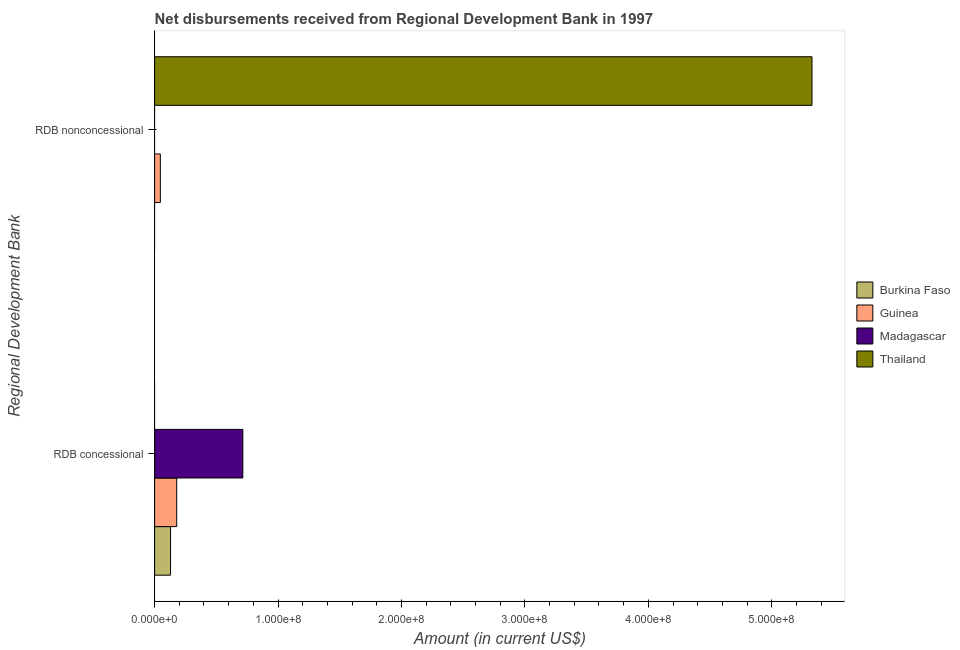Are the number of bars per tick equal to the number of legend labels?
Provide a succinct answer. No. Are the number of bars on each tick of the Y-axis equal?
Your response must be concise. No. How many bars are there on the 2nd tick from the top?
Ensure brevity in your answer.  3. How many bars are there on the 1st tick from the bottom?
Provide a short and direct response. 3. What is the label of the 1st group of bars from the top?
Your response must be concise. RDB nonconcessional. What is the net concessional disbursements from rdb in Madagascar?
Give a very brief answer. 7.15e+07. Across all countries, what is the maximum net concessional disbursements from rdb?
Offer a very short reply. 7.15e+07. Across all countries, what is the minimum net concessional disbursements from rdb?
Ensure brevity in your answer.  0. In which country was the net concessional disbursements from rdb maximum?
Offer a very short reply. Madagascar. What is the total net concessional disbursements from rdb in the graph?
Give a very brief answer. 1.02e+08. What is the difference between the net concessional disbursements from rdb in Madagascar and that in Burkina Faso?
Keep it short and to the point. 5.86e+07. What is the difference between the net concessional disbursements from rdb in Burkina Faso and the net non concessional disbursements from rdb in Thailand?
Your answer should be compact. -5.20e+08. What is the average net concessional disbursements from rdb per country?
Offer a very short reply. 2.56e+07. What is the difference between the net concessional disbursements from rdb and net non concessional disbursements from rdb in Guinea?
Give a very brief answer. 1.33e+07. In how many countries, is the net concessional disbursements from rdb greater than 200000000 US$?
Give a very brief answer. 0. What is the ratio of the net concessional disbursements from rdb in Burkina Faso to that in Madagascar?
Offer a very short reply. 0.18. In how many countries, is the net concessional disbursements from rdb greater than the average net concessional disbursements from rdb taken over all countries?
Your response must be concise. 1. How many countries are there in the graph?
Keep it short and to the point. 4. Does the graph contain any zero values?
Give a very brief answer. Yes. Where does the legend appear in the graph?
Keep it short and to the point. Center right. How are the legend labels stacked?
Your answer should be compact. Vertical. What is the title of the graph?
Provide a succinct answer. Net disbursements received from Regional Development Bank in 1997. What is the label or title of the X-axis?
Your answer should be very brief. Amount (in current US$). What is the label or title of the Y-axis?
Keep it short and to the point. Regional Development Bank. What is the Amount (in current US$) of Burkina Faso in RDB concessional?
Provide a succinct answer. 1.29e+07. What is the Amount (in current US$) in Guinea in RDB concessional?
Your answer should be compact. 1.79e+07. What is the Amount (in current US$) in Madagascar in RDB concessional?
Your answer should be very brief. 7.15e+07. What is the Amount (in current US$) of Burkina Faso in RDB nonconcessional?
Keep it short and to the point. 0. What is the Amount (in current US$) of Guinea in RDB nonconcessional?
Your answer should be compact. 4.65e+06. What is the Amount (in current US$) of Madagascar in RDB nonconcessional?
Offer a terse response. 0. What is the Amount (in current US$) in Thailand in RDB nonconcessional?
Make the answer very short. 5.33e+08. Across all Regional Development Bank, what is the maximum Amount (in current US$) of Burkina Faso?
Provide a short and direct response. 1.29e+07. Across all Regional Development Bank, what is the maximum Amount (in current US$) of Guinea?
Offer a very short reply. 1.79e+07. Across all Regional Development Bank, what is the maximum Amount (in current US$) of Madagascar?
Offer a terse response. 7.15e+07. Across all Regional Development Bank, what is the maximum Amount (in current US$) in Thailand?
Your answer should be compact. 5.33e+08. Across all Regional Development Bank, what is the minimum Amount (in current US$) in Guinea?
Provide a succinct answer. 4.65e+06. Across all Regional Development Bank, what is the minimum Amount (in current US$) of Madagascar?
Ensure brevity in your answer.  0. What is the total Amount (in current US$) of Burkina Faso in the graph?
Your answer should be compact. 1.29e+07. What is the total Amount (in current US$) of Guinea in the graph?
Make the answer very short. 2.26e+07. What is the total Amount (in current US$) of Madagascar in the graph?
Make the answer very short. 7.15e+07. What is the total Amount (in current US$) in Thailand in the graph?
Keep it short and to the point. 5.33e+08. What is the difference between the Amount (in current US$) in Guinea in RDB concessional and that in RDB nonconcessional?
Your answer should be compact. 1.33e+07. What is the difference between the Amount (in current US$) of Burkina Faso in RDB concessional and the Amount (in current US$) of Guinea in RDB nonconcessional?
Offer a very short reply. 8.26e+06. What is the difference between the Amount (in current US$) in Burkina Faso in RDB concessional and the Amount (in current US$) in Thailand in RDB nonconcessional?
Offer a very short reply. -5.20e+08. What is the difference between the Amount (in current US$) of Guinea in RDB concessional and the Amount (in current US$) of Thailand in RDB nonconcessional?
Offer a very short reply. -5.15e+08. What is the difference between the Amount (in current US$) of Madagascar in RDB concessional and the Amount (in current US$) of Thailand in RDB nonconcessional?
Your answer should be compact. -4.61e+08. What is the average Amount (in current US$) of Burkina Faso per Regional Development Bank?
Provide a succinct answer. 6.45e+06. What is the average Amount (in current US$) of Guinea per Regional Development Bank?
Your answer should be compact. 1.13e+07. What is the average Amount (in current US$) of Madagascar per Regional Development Bank?
Make the answer very short. 3.57e+07. What is the average Amount (in current US$) in Thailand per Regional Development Bank?
Give a very brief answer. 2.66e+08. What is the difference between the Amount (in current US$) of Burkina Faso and Amount (in current US$) of Guinea in RDB concessional?
Your answer should be very brief. -5.01e+06. What is the difference between the Amount (in current US$) of Burkina Faso and Amount (in current US$) of Madagascar in RDB concessional?
Keep it short and to the point. -5.86e+07. What is the difference between the Amount (in current US$) of Guinea and Amount (in current US$) of Madagascar in RDB concessional?
Your answer should be very brief. -5.36e+07. What is the difference between the Amount (in current US$) in Guinea and Amount (in current US$) in Thailand in RDB nonconcessional?
Ensure brevity in your answer.  -5.28e+08. What is the ratio of the Amount (in current US$) in Guinea in RDB concessional to that in RDB nonconcessional?
Give a very brief answer. 3.85. What is the difference between the highest and the second highest Amount (in current US$) in Guinea?
Offer a very short reply. 1.33e+07. What is the difference between the highest and the lowest Amount (in current US$) in Burkina Faso?
Provide a short and direct response. 1.29e+07. What is the difference between the highest and the lowest Amount (in current US$) of Guinea?
Offer a terse response. 1.33e+07. What is the difference between the highest and the lowest Amount (in current US$) in Madagascar?
Provide a short and direct response. 7.15e+07. What is the difference between the highest and the lowest Amount (in current US$) in Thailand?
Your answer should be very brief. 5.33e+08. 